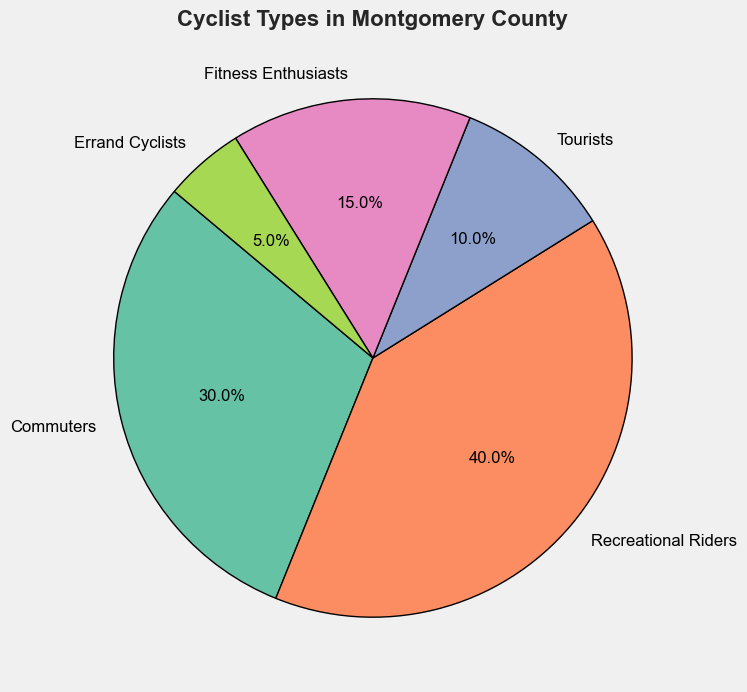What is the largest group of cyclists? By looking at the pie chart, we identify that "Recreational Riders" takes up the largest portion of the pie. This indicates they are the largest group.
Answer: Recreational Riders How many more commuters are there compared to errand cyclists? From the pie chart, commuters are 30% and errand cyclists are 5%. Subtract the percentage of errand cyclists from that of commuters (30% - 5% = 25%).
Answer: 25% What is the combined percentage of fitness enthusiasts and tourists? Sum up the percentages of fitness enthusiasts and tourists from the pie chart: 15% + 10% = 25%.
Answer: 25% Which group makes up the smallest portion of cyclists? From the pie chart, the smallest section is clearly labeled as "Errand Cyclists" with a percentage of 5%.
Answer: Errand Cyclists Are there more commuters or tourists? By comparing the pie segments, commuters (30%) make up a bigger portion than tourists (10%).
Answer: Commuters What percentage of cyclists are either recreational riders or fitness enthusiasts? Add the percentages of recreational riders and fitness enthusiasts: 40% + 15% = 55%.
Answer: 55% Which two groups together make up half of the cyclists? To find the combination that equals 50%, check the pair: Recreational Riders (40%) and Fitness Enthusiasts (15%) totals 55%, but Recreational Riders (40%) and Tourists (10%) total exactly 50%.
Answer: Recreational Riders and Tourists What color represents the recreational riders in the pie chart? The pie chart uses different colors for each segment. The section labeled "Recreational Riders" matches the green color in the chart.
Answer: Green How do the percentages of commuters and recreational riders compare? Commuters account for 30% and recreational riders for 40%. By comparing the two, recreational riders have a larger percentage.
Answer: Recreational Riders have a larger percentage 